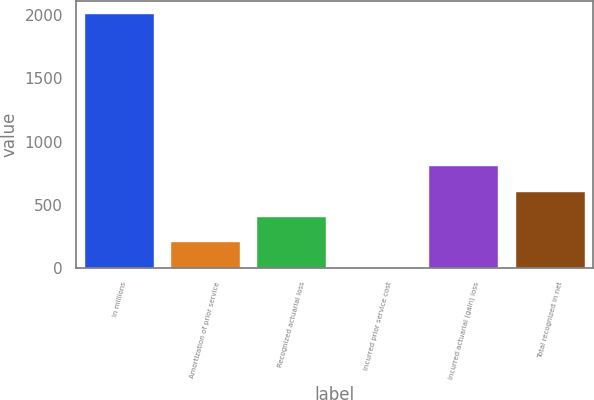<chart> <loc_0><loc_0><loc_500><loc_500><bar_chart><fcel>In millions<fcel>Amortization of prior service<fcel>Recognized actuarial loss<fcel>Incurred prior service cost<fcel>Incurred actuarial (gain) loss<fcel>Total recognized in net<nl><fcel>2010<fcel>201.9<fcel>402.8<fcel>1<fcel>804.6<fcel>603.7<nl></chart> 